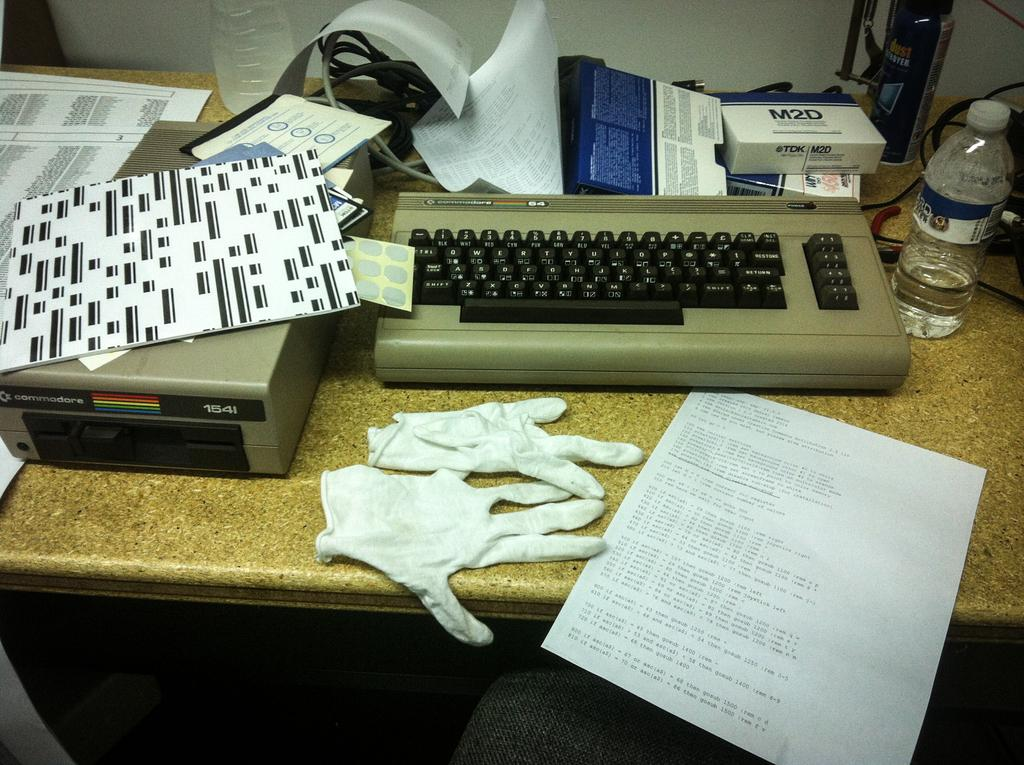Provide a one-sentence caption for the provided image. A box with the brand name M2D on it is on top of a typewriter. 